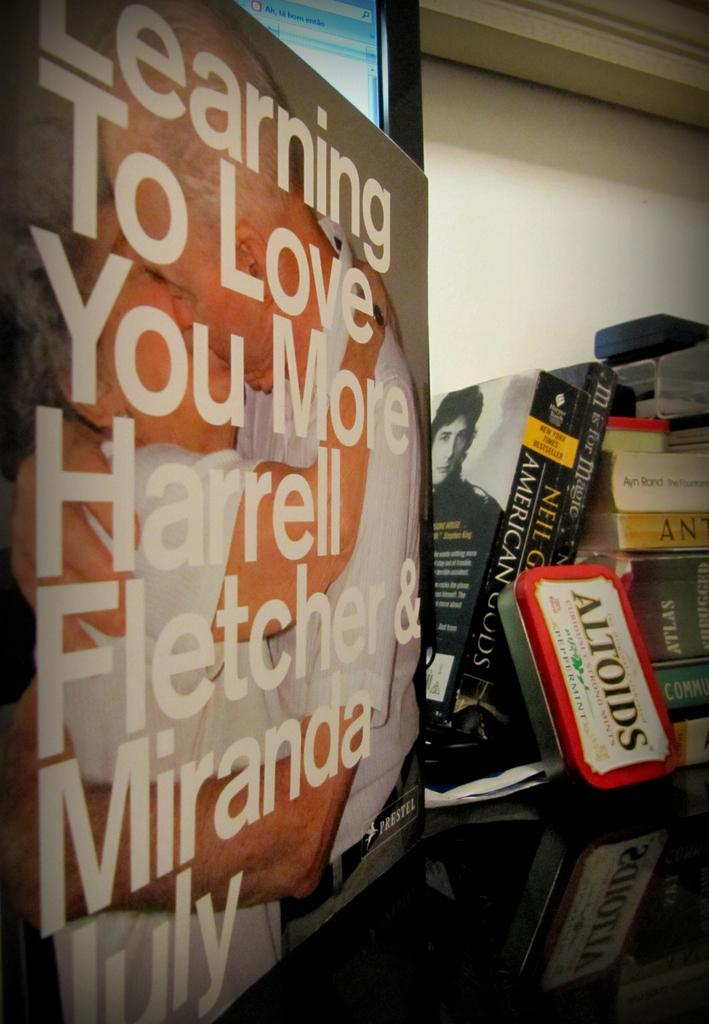Provide a one-sentence caption for the provided image. A sign that reads learning to love you more by Harrell Fletcher. 